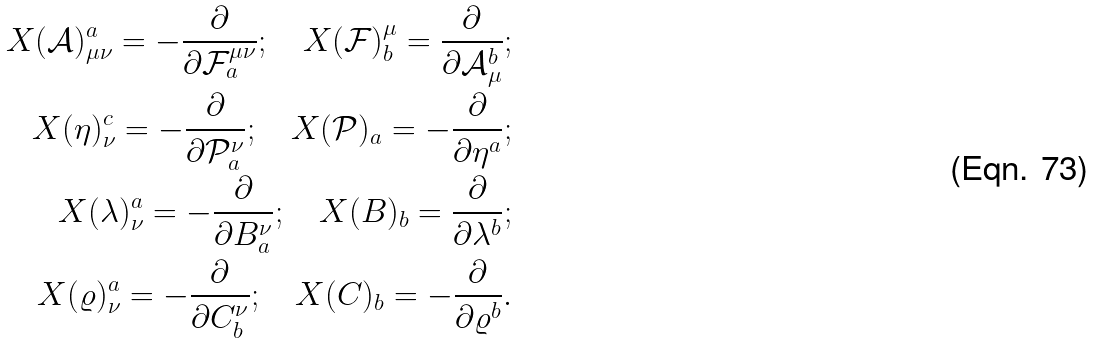Convert formula to latex. <formula><loc_0><loc_0><loc_500><loc_500>X ( \mathcal { A } ) ^ { a } _ { \mu \nu } = - \frac { \partial } { \partial \mathcal { F } _ { a } ^ { \mu \nu } } ; \quad X ( \mathcal { F } ) _ { b } ^ { \mu } = \frac { \partial } { \partial \mathcal { A } ^ { b } _ { \mu } } ; \\ X ( \eta ) ^ { c } _ { \nu } = - \frac { \partial } { \partial \mathcal { P } _ { a } ^ { \nu } } ; \quad X ( \mathcal { P } ) _ { a } = - \frac { \partial } { \partial \eta ^ { a } } ; \\ X ( \lambda ) ^ { a } _ { \nu } = - \frac { \partial } { \partial B _ { a } ^ { \nu } } ; \quad X ( B ) _ { b } = \frac { \partial } { \partial \lambda ^ { b } } ; \\ X ( \varrho ) ^ { a } _ { \nu } = - \frac { \partial } { \partial C _ { b } ^ { \nu } } ; \quad X ( C ) _ { b } = - \frac { \partial } { \partial \varrho ^ { b } } .</formula> 